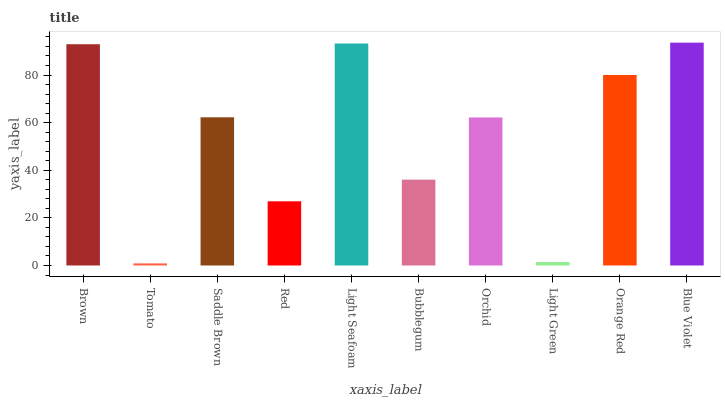Is Tomato the minimum?
Answer yes or no. Yes. Is Blue Violet the maximum?
Answer yes or no. Yes. Is Saddle Brown the minimum?
Answer yes or no. No. Is Saddle Brown the maximum?
Answer yes or no. No. Is Saddle Brown greater than Tomato?
Answer yes or no. Yes. Is Tomato less than Saddle Brown?
Answer yes or no. Yes. Is Tomato greater than Saddle Brown?
Answer yes or no. No. Is Saddle Brown less than Tomato?
Answer yes or no. No. Is Saddle Brown the high median?
Answer yes or no. Yes. Is Orchid the low median?
Answer yes or no. Yes. Is Light Green the high median?
Answer yes or no. No. Is Saddle Brown the low median?
Answer yes or no. No. 